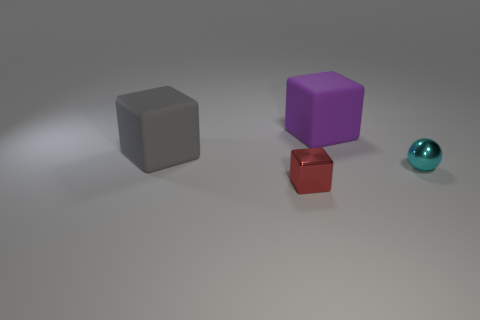Add 4 gray things. How many objects exist? 8 Subtract all tiny red metallic blocks. How many blocks are left? 2 Subtract all spheres. How many objects are left? 3 Add 3 cyan spheres. How many cyan spheres are left? 4 Add 4 tiny red shiny cylinders. How many tiny red shiny cylinders exist? 4 Subtract 0 blue cylinders. How many objects are left? 4 Subtract all brown blocks. Subtract all cyan balls. How many blocks are left? 3 Subtract all big purple blocks. Subtract all red cubes. How many objects are left? 2 